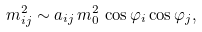Convert formula to latex. <formula><loc_0><loc_0><loc_500><loc_500>m _ { i j } ^ { 2 } \sim a _ { i j } \, m _ { 0 } ^ { 2 } \, \cos \varphi _ { i } \cos \varphi _ { j } ,</formula> 